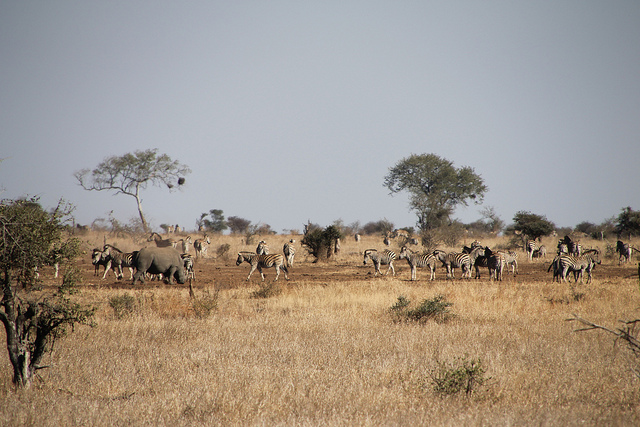How might the weather affect the animals in this habitat? In a dry environment such as this, animals have adapted to the arid conditions. They would pace their water consumption and reduce activity during the hottest times of the day to conserve energy and moisture. 